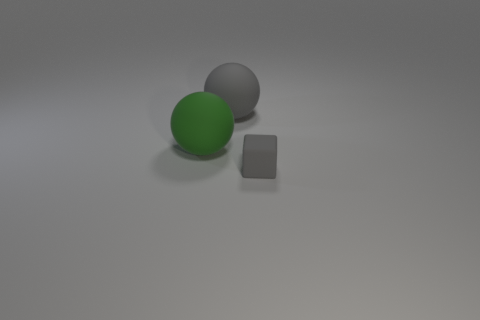Add 1 large matte things. How many objects exist? 4 Subtract all cubes. How many objects are left? 2 Add 1 large green matte balls. How many large green matte balls are left? 2 Add 2 rubber blocks. How many rubber blocks exist? 3 Subtract 0 purple cubes. How many objects are left? 3 Subtract all small cyan cylinders. Subtract all rubber spheres. How many objects are left? 1 